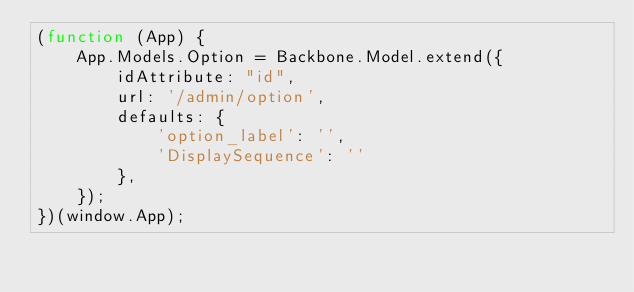Convert code to text. <code><loc_0><loc_0><loc_500><loc_500><_JavaScript_>(function (App) {
    App.Models.Option = Backbone.Model.extend({
        idAttribute: "id",
        url: '/admin/option',
        defaults: {
            'option_label': '',
            'DisplaySequence': ''
        },
    });
})(window.App);
</code> 